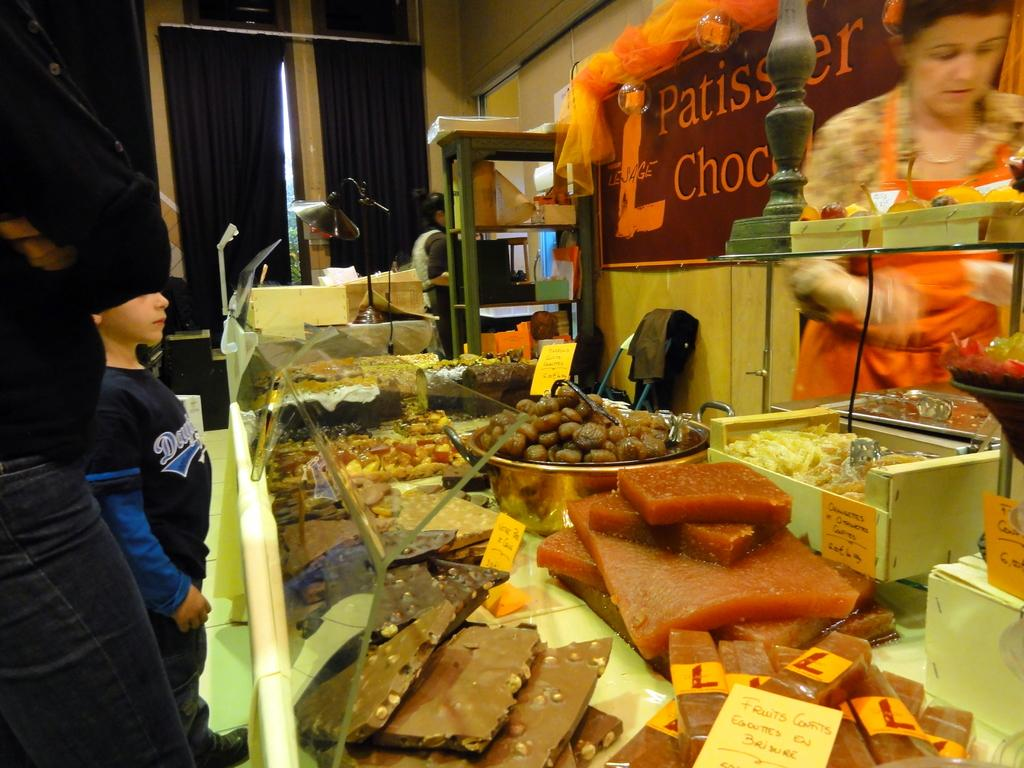<image>
Render a clear and concise summary of the photo. A display case at a bakery with a sign in orange letters reading Patissier Choc. 